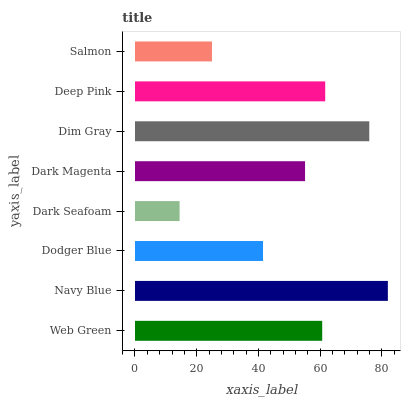Is Dark Seafoam the minimum?
Answer yes or no. Yes. Is Navy Blue the maximum?
Answer yes or no. Yes. Is Dodger Blue the minimum?
Answer yes or no. No. Is Dodger Blue the maximum?
Answer yes or no. No. Is Navy Blue greater than Dodger Blue?
Answer yes or no. Yes. Is Dodger Blue less than Navy Blue?
Answer yes or no. Yes. Is Dodger Blue greater than Navy Blue?
Answer yes or no. No. Is Navy Blue less than Dodger Blue?
Answer yes or no. No. Is Web Green the high median?
Answer yes or no. Yes. Is Dark Magenta the low median?
Answer yes or no. Yes. Is Dark Magenta the high median?
Answer yes or no. No. Is Dim Gray the low median?
Answer yes or no. No. 